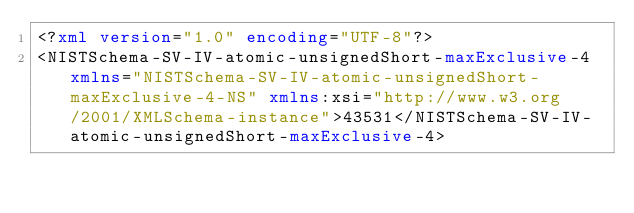<code> <loc_0><loc_0><loc_500><loc_500><_XML_><?xml version="1.0" encoding="UTF-8"?>
<NISTSchema-SV-IV-atomic-unsignedShort-maxExclusive-4 xmlns="NISTSchema-SV-IV-atomic-unsignedShort-maxExclusive-4-NS" xmlns:xsi="http://www.w3.org/2001/XMLSchema-instance">43531</NISTSchema-SV-IV-atomic-unsignedShort-maxExclusive-4>
</code> 